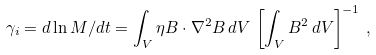<formula> <loc_0><loc_0><loc_500><loc_500>\gamma _ { i } = { d \ln M } / { d t } = \int _ { V } \eta B \cdot \nabla ^ { 2 } B \, d V \, \left [ \int _ { V } B ^ { 2 } \, d V \right ] ^ { - 1 } \, ,</formula> 